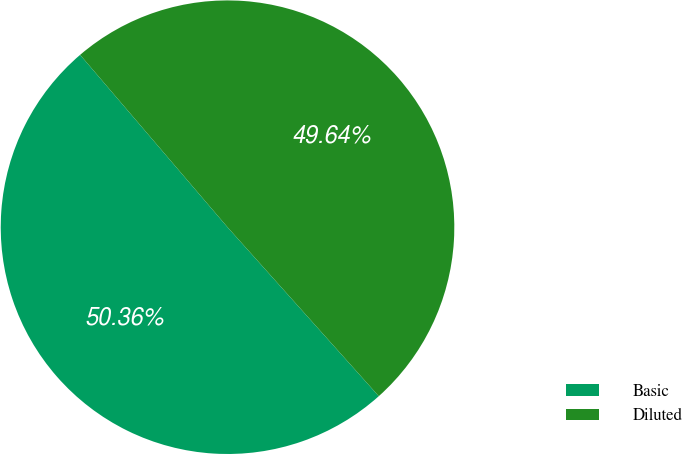Convert chart to OTSL. <chart><loc_0><loc_0><loc_500><loc_500><pie_chart><fcel>Basic<fcel>Diluted<nl><fcel>50.36%<fcel>49.64%<nl></chart> 